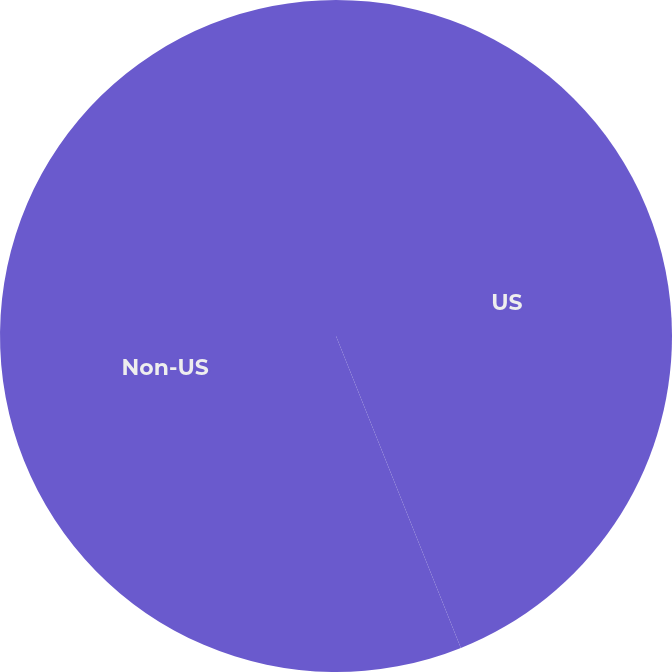<chart> <loc_0><loc_0><loc_500><loc_500><pie_chart><fcel>US<fcel>Non-US<nl><fcel>43.94%<fcel>56.06%<nl></chart> 